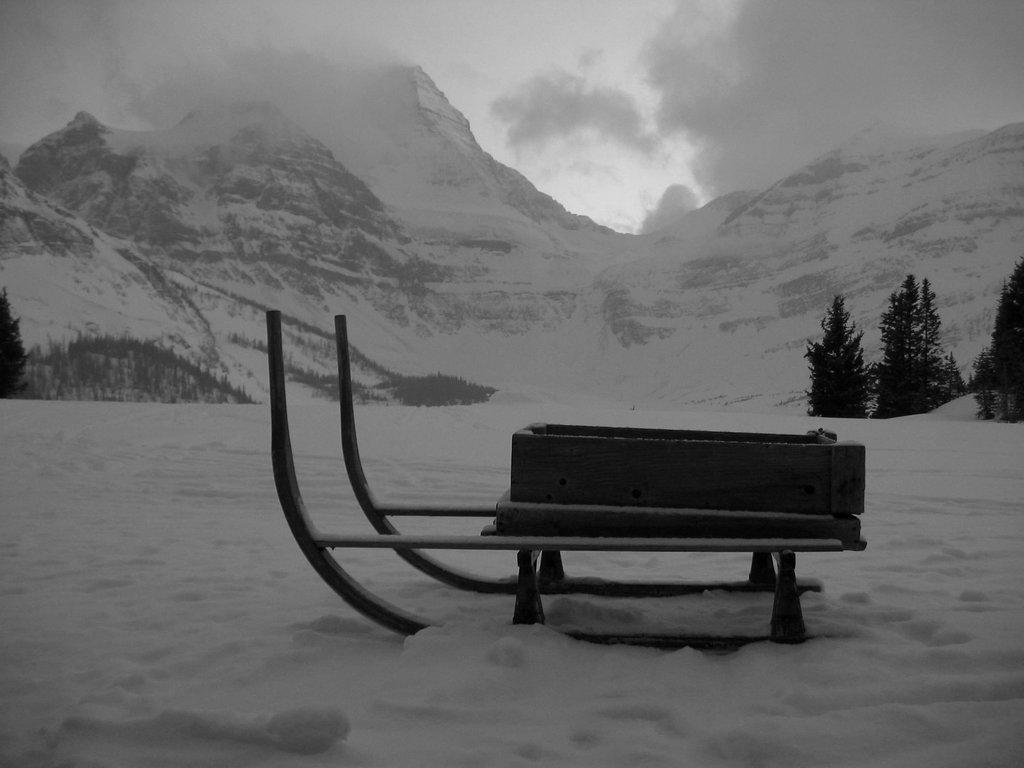What is the main object on the snow in the image? There is a sledge on the snow in the image. What type of natural features can be seen in the image? There are trees and mountains visible in the image. What is visible in the background of the image? The sky is visible in the background of the image, with clouds present. What is the color scheme of the image? The image is black and white. Can you tell me how many loaves of bread are on the sledge in the image? There is no loaf of bread present in the image; it features a sledge on the snow. What type of conversation is happening between the trees in the image? There is no conversation happening between the trees in the image, as trees do not have the ability to talk. 